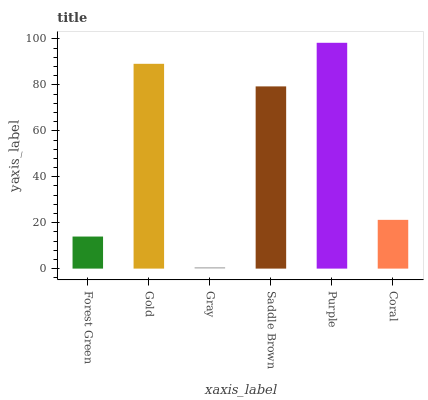Is Gray the minimum?
Answer yes or no. Yes. Is Purple the maximum?
Answer yes or no. Yes. Is Gold the minimum?
Answer yes or no. No. Is Gold the maximum?
Answer yes or no. No. Is Gold greater than Forest Green?
Answer yes or no. Yes. Is Forest Green less than Gold?
Answer yes or no. Yes. Is Forest Green greater than Gold?
Answer yes or no. No. Is Gold less than Forest Green?
Answer yes or no. No. Is Saddle Brown the high median?
Answer yes or no. Yes. Is Coral the low median?
Answer yes or no. Yes. Is Forest Green the high median?
Answer yes or no. No. Is Gold the low median?
Answer yes or no. No. 